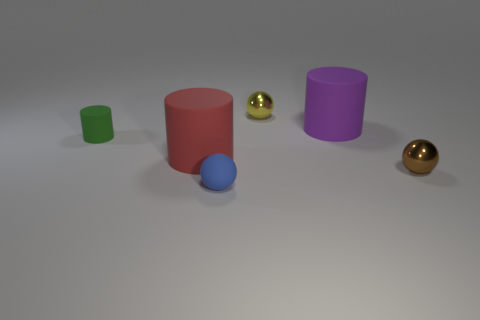Add 1 large purple rubber things. How many objects exist? 7 Subtract all small brown spheres. How many spheres are left? 2 Subtract 0 brown cylinders. How many objects are left? 6 Subtract all cyan balls. Subtract all purple cylinders. How many balls are left? 3 Subtract all blue matte objects. Subtract all matte cylinders. How many objects are left? 2 Add 1 red cylinders. How many red cylinders are left? 2 Add 4 yellow cylinders. How many yellow cylinders exist? 4 